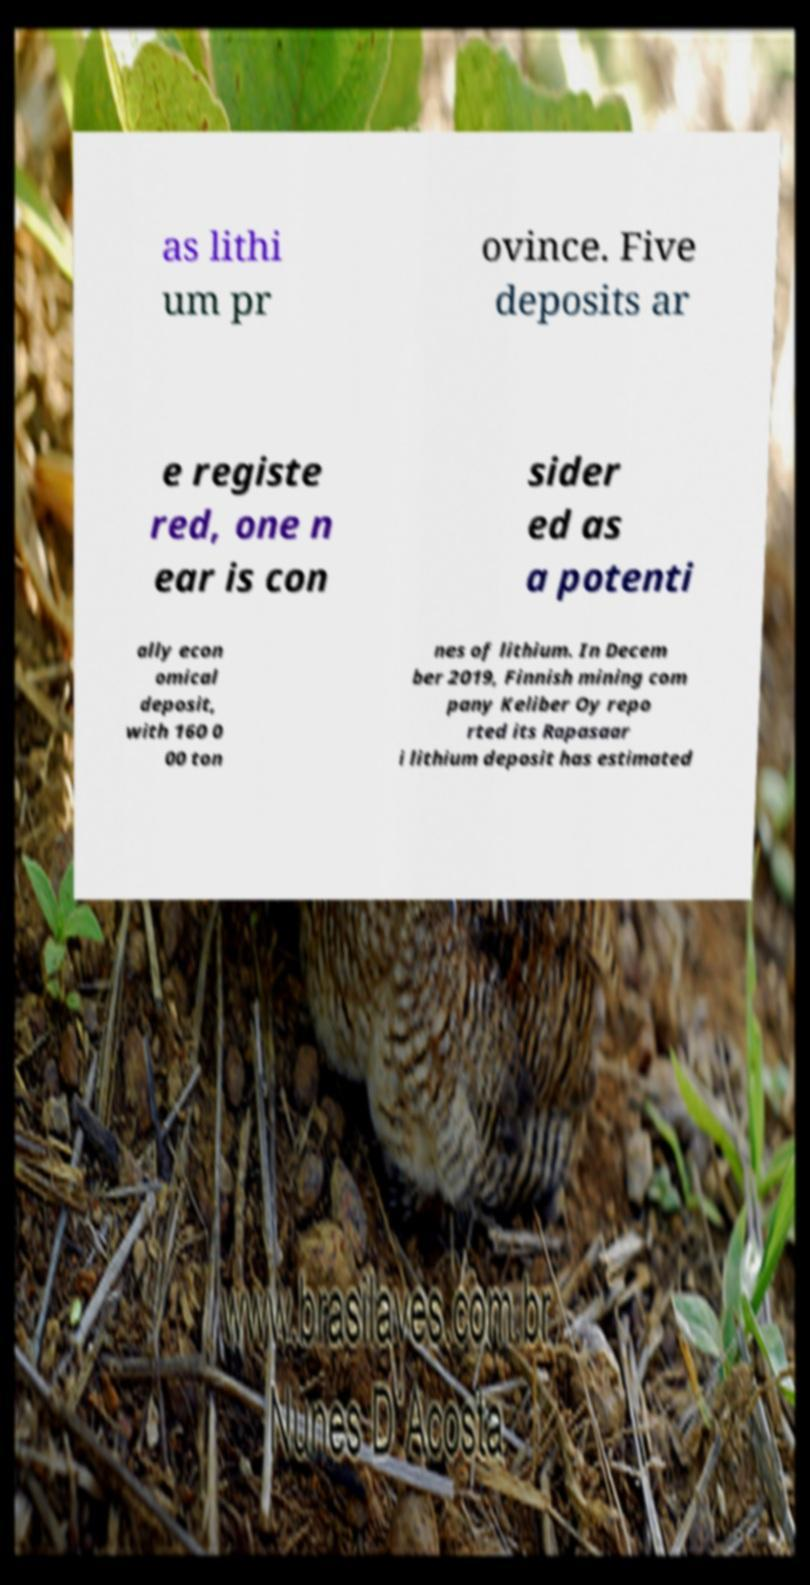Can you read and provide the text displayed in the image?This photo seems to have some interesting text. Can you extract and type it out for me? as lithi um pr ovince. Five deposits ar e registe red, one n ear is con sider ed as a potenti ally econ omical deposit, with 160 0 00 ton nes of lithium. In Decem ber 2019, Finnish mining com pany Keliber Oy repo rted its Rapasaar i lithium deposit has estimated 